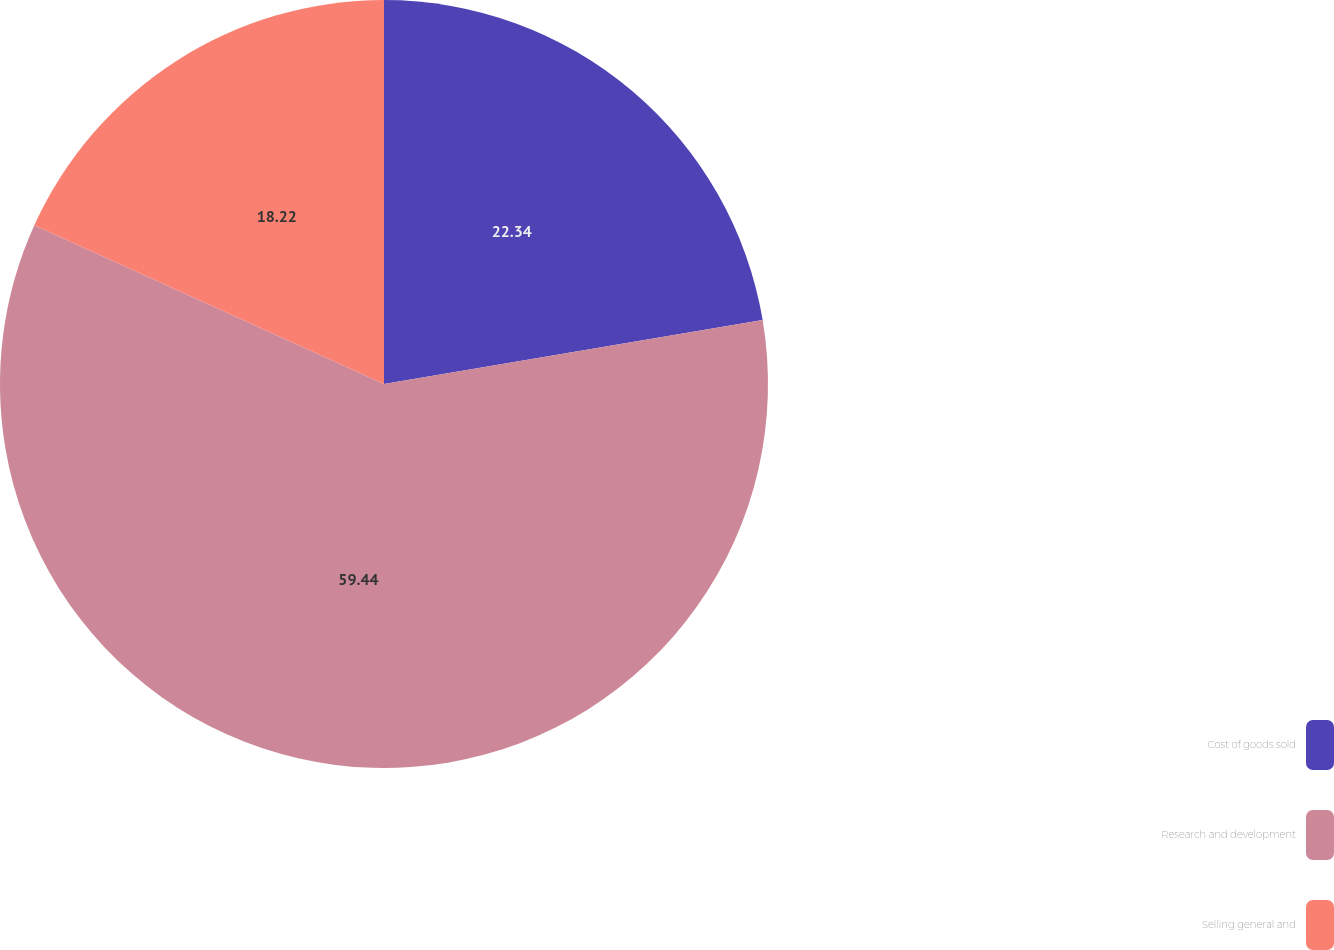<chart> <loc_0><loc_0><loc_500><loc_500><pie_chart><fcel>Cost of goods sold<fcel>Research and development<fcel>Selling general and<nl><fcel>22.34%<fcel>59.44%<fcel>18.22%<nl></chart> 